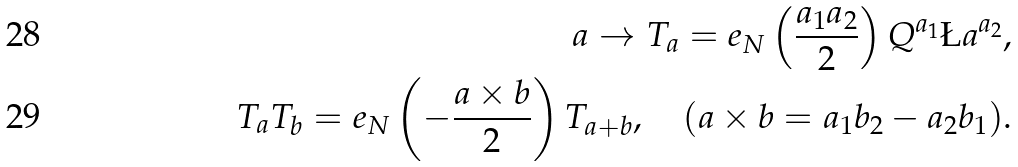Convert formula to latex. <formula><loc_0><loc_0><loc_500><loc_500>a \to T _ { a } = e _ { N } \left ( \frac { a _ { 1 } a _ { 2 } } { 2 } \right ) Q ^ { a _ { 1 } } \L a ^ { a _ { 2 } } , \\ T _ { a } T _ { b } = e _ { N } \left ( - \frac { a \times b } { 2 } \right ) T _ { a + b } , \quad ( a \times b = a _ { 1 } b _ { 2 } - a _ { 2 } b _ { 1 } ) .</formula> 